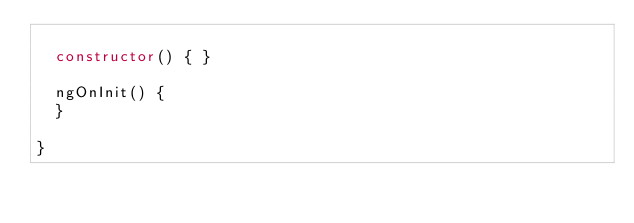Convert code to text. <code><loc_0><loc_0><loc_500><loc_500><_TypeScript_>
  constructor() { }

  ngOnInit() {
  }

}
</code> 